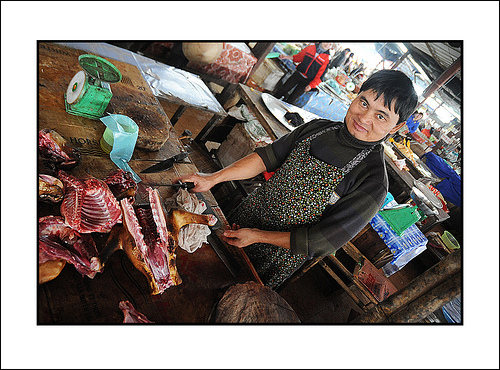<image>
Can you confirm if the knife is on the meat? No. The knife is not positioned on the meat. They may be near each other, but the knife is not supported by or resting on top of the meat. 